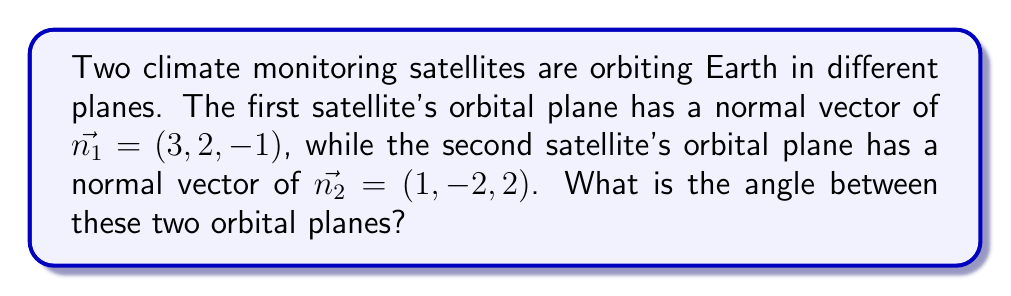Can you answer this question? To find the angle between two planes, we can use the dot product of their normal vectors. The formula for the angle $\theta$ between two planes is:

$$\cos \theta = \frac{|\vec{n_1} \cdot \vec{n_2}|}{\|\vec{n_1}\| \|\vec{n_2}\|}$$

Step 1: Calculate the dot product $\vec{n_1} \cdot \vec{n_2}$
$$\vec{n_1} \cdot \vec{n_2} = (3)(1) + (2)(-2) + (-1)(2) = 3 - 4 - 2 = -3$$

Step 2: Calculate the magnitudes of $\vec{n_1}$ and $\vec{n_2}$
$$\|\vec{n_1}\| = \sqrt{3^2 + 2^2 + (-1)^2} = \sqrt{14}$$
$$\|\vec{n_2}\| = \sqrt{1^2 + (-2)^2 + 2^2} = 3$$

Step 3: Apply the formula
$$\cos \theta = \frac{|-3|}{\sqrt{14} \cdot 3} = \frac{3}{\sqrt{14} \cdot 3} = \frac{1}{\sqrt{14}}$$

Step 4: Take the inverse cosine (arccos) of both sides
$$\theta = \arccos(\frac{1}{\sqrt{14}})$$

Step 5: Calculate the result (in radians)
$$\theta \approx 1.3254$$

Step 6: Convert to degrees
$$\theta \approx 75.97°$$
Answer: $75.97°$ 